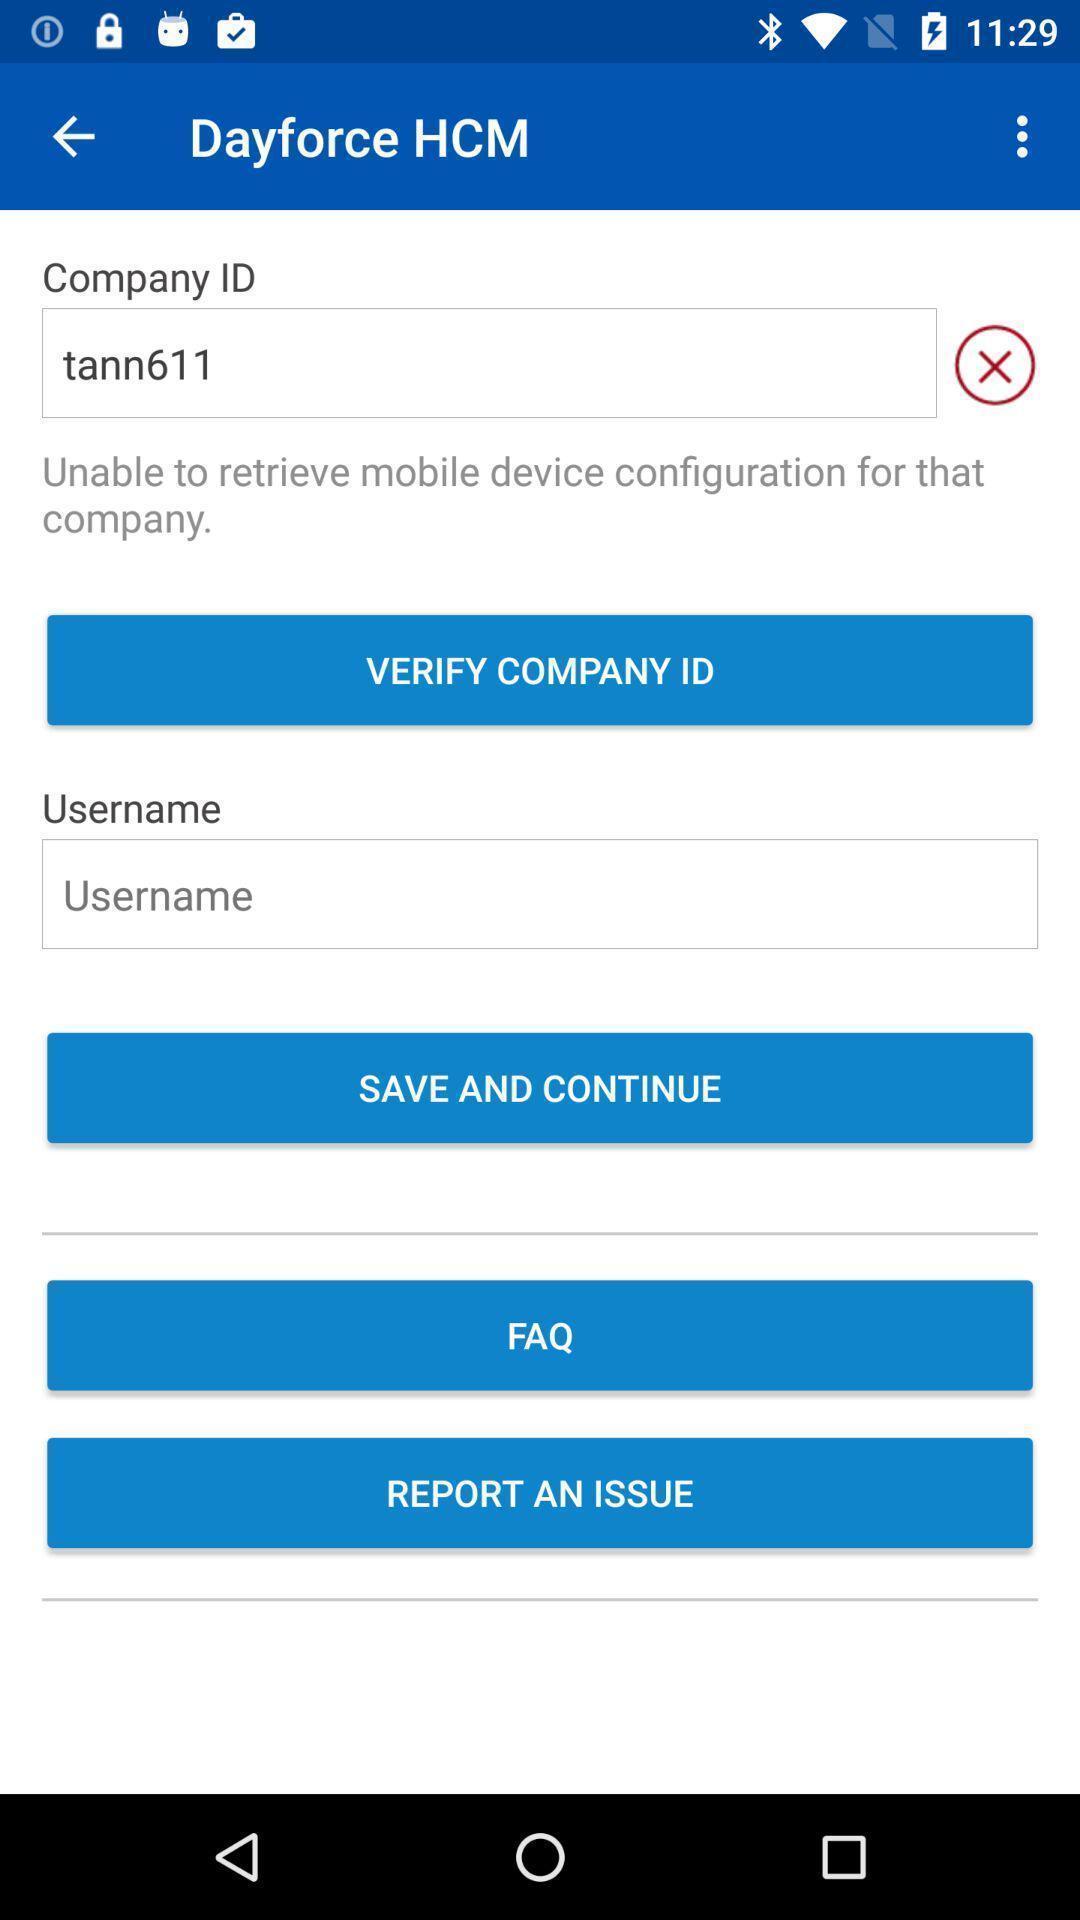Describe the key features of this screenshot. Page to verify company id in the work managing app. 